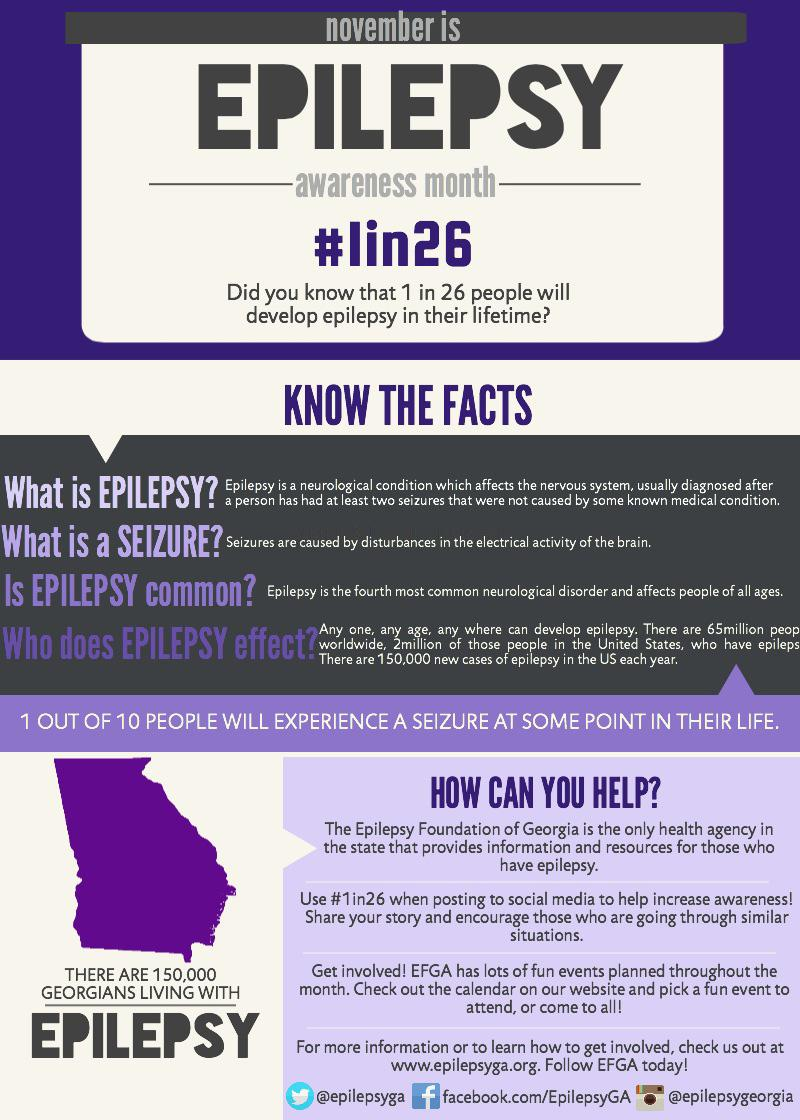Specify some key components in this picture. In the state of Georgia, it is estimated that approximately 150,000 people are affected by epilepsy. Epilepsy is characterized by recurrent seizures, which are caused by disturbances in the electrical activity of the brain. 